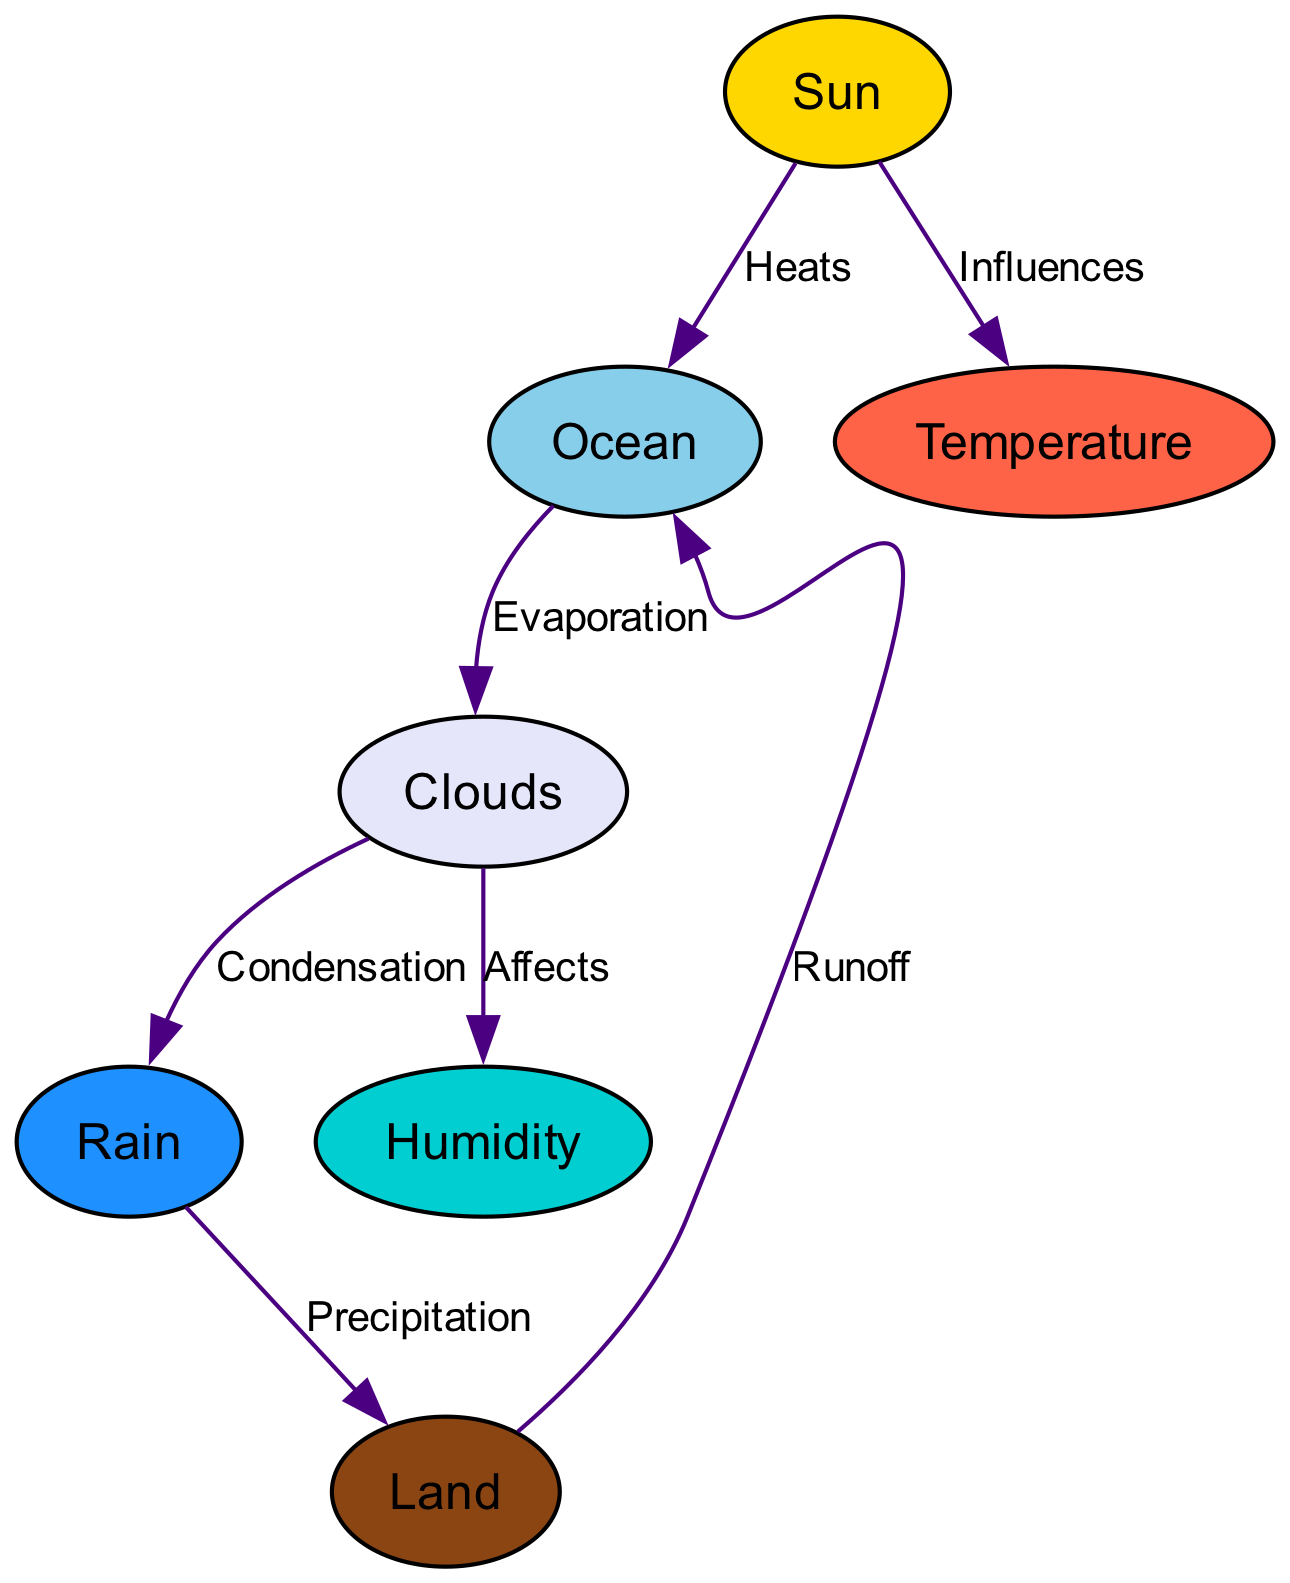What is the starting point of the water cycle in the diagram? The starting point is the "Ocean," which is the first node where evaporation occurs due to heating from the sun.
Answer: Ocean How many nodes are present in the diagram? By counting the distinct entities in the diagram, we find there are seven nodes in total: Ocean, Sun, Clouds, Rain, Land, Humidity, and Temperature.
Answer: 7 What process connects the clouds to rain? The connection is labeled as "Condensation," showing the transition from clouds to rain as the moisture condenses.
Answer: Condensation What does the sun influence in this diagram? The sun influences "Temperature," as indicated by the directed edge labeled "Influences" from the sun node to the temperature node.
Answer: Temperature Which process occurs directly after evaporation in the water cycle? After evaporation, the process that occurs next is "Condensation," where the water vapor in clouds begins to condense into droplets.
Answer: Condensation What relationship exists between clouds and humidity? The relationship is that clouds "Affect" humidity; this indicates that the presence of clouds impacts the level of humidity in the atmosphere.
Answer: Affects Which node represents the form in which water falls to the ground? The node that represents the form in which water falls to the ground is "Rain," denoting the precipitation phase in the water cycle.
Answer: Rain Where does the water from rain eventually flow to? The water from rain eventually flows to "Land," indicating the destination of precipitation before moving into runoff or other processes.
Answer: Land How does temperature relate to the sun in this diagram? Temperature is influenced by the sun, as illustrated by the edge that connects the sun to the temperature node with the label "Influences."
Answer: Influences 